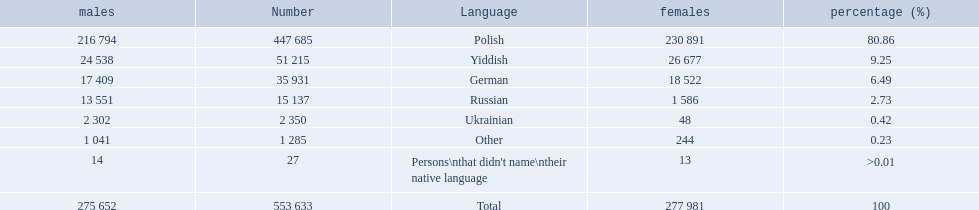What language makes a majority Polish. What the the total number of speakers? 553 633. 